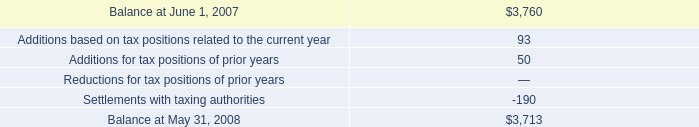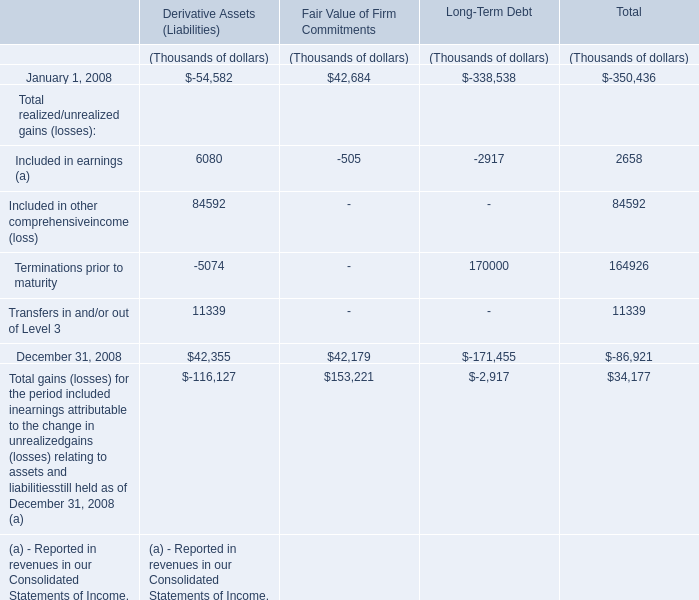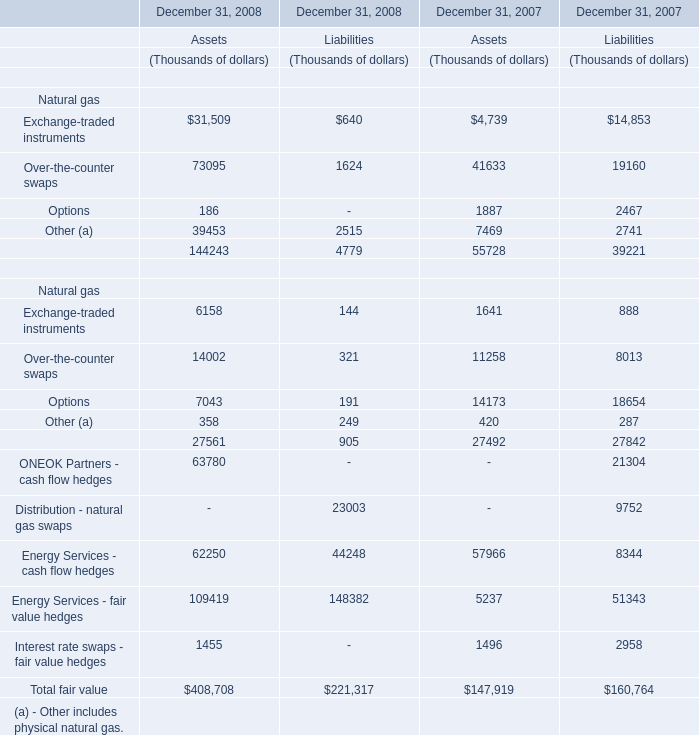What's the total value of all Derivative Assets (Liabilities) that are smaller than 0 in 2008? (in Thousand) 
Computations: ((-54582 - 5074) - 116127)
Answer: -175783.0. 